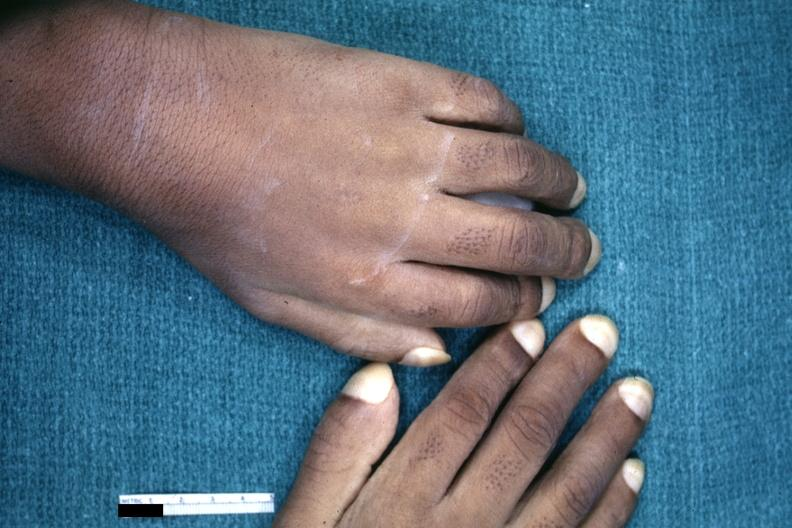does slide show childs hands with obvious clubbing?
Answer the question using a single word or phrase. No 